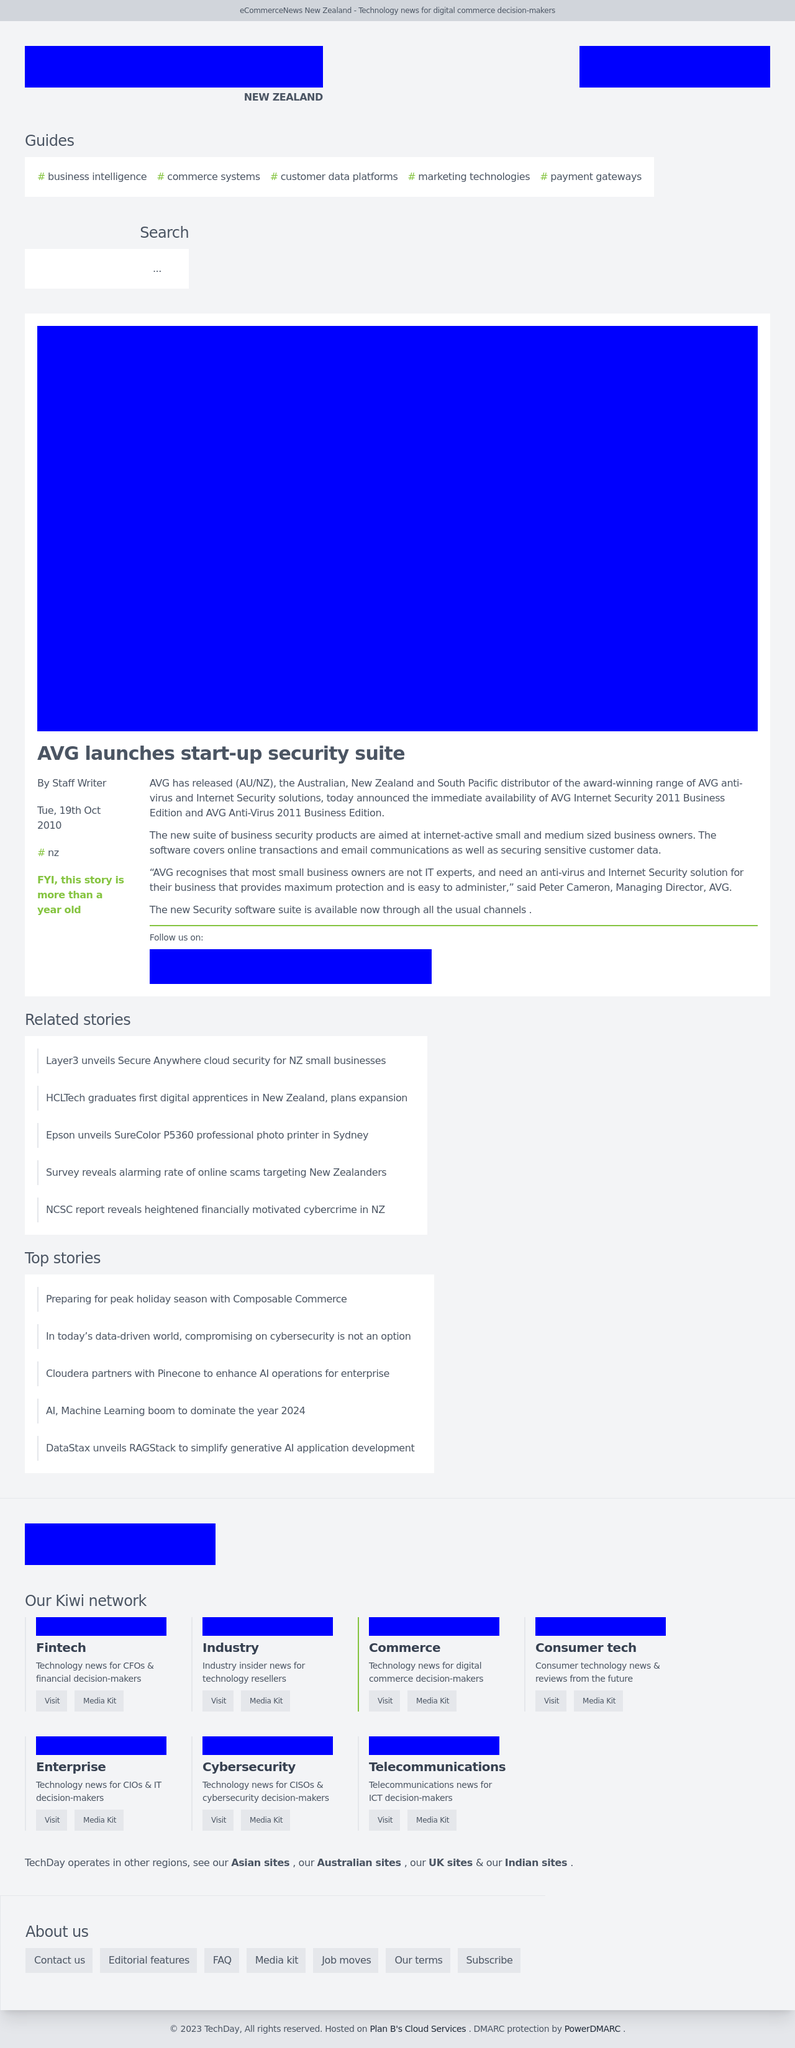What suggestions do you have for improving user engagement on this type of webpage? To boost user engagement on this webpage, consider integrating interactive elements such as multimedia content like videos or podcasts, user comments, or forums for discussion. Moreover, offering personalized content recommendations based on user interests or past behavior, as well as engaging calls-to-action that invite readers to subscribe or download resources, can significantly enhance engagement. 